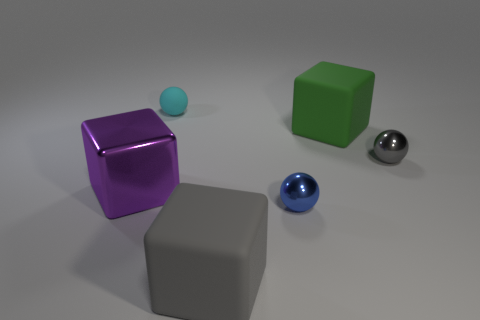What number of metallic things are either green cubes or tiny cyan things?
Keep it short and to the point. 0. Is the number of matte blocks to the left of the blue sphere greater than the number of small brown rubber blocks?
Offer a terse response. Yes. How many other things are made of the same material as the small gray sphere?
Your response must be concise. 2. What number of tiny things are either blue balls or yellow shiny cylinders?
Your answer should be very brief. 1. Do the tiny blue thing and the big gray block have the same material?
Your answer should be compact. No. What number of tiny gray metallic spheres are left of the big thing that is in front of the tiny blue metallic sphere?
Your answer should be compact. 0. Are there any gray shiny things of the same shape as the large purple object?
Make the answer very short. No. There is a object on the left side of the cyan object; does it have the same shape as the gray object that is in front of the gray metal thing?
Ensure brevity in your answer.  Yes. What shape is the big object that is both to the right of the big purple metal cube and in front of the tiny gray ball?
Provide a short and direct response. Cube. Are there any rubber cubes of the same size as the gray matte thing?
Your answer should be compact. Yes. 